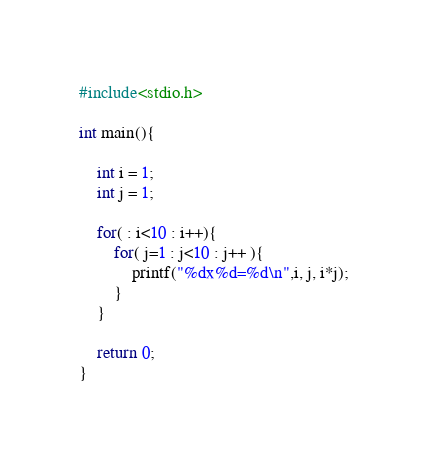<code> <loc_0><loc_0><loc_500><loc_500><_C_>#include<stdio.h>

int main(){
    
    int i = 1;
    int j = 1;

    for( : i<10 : i++){
        for( j=1 : j<10 : j++ ){
            printf("%dx%d=%d\n",i, j, i*j);
        }
    } 

    return 0;
}</code> 